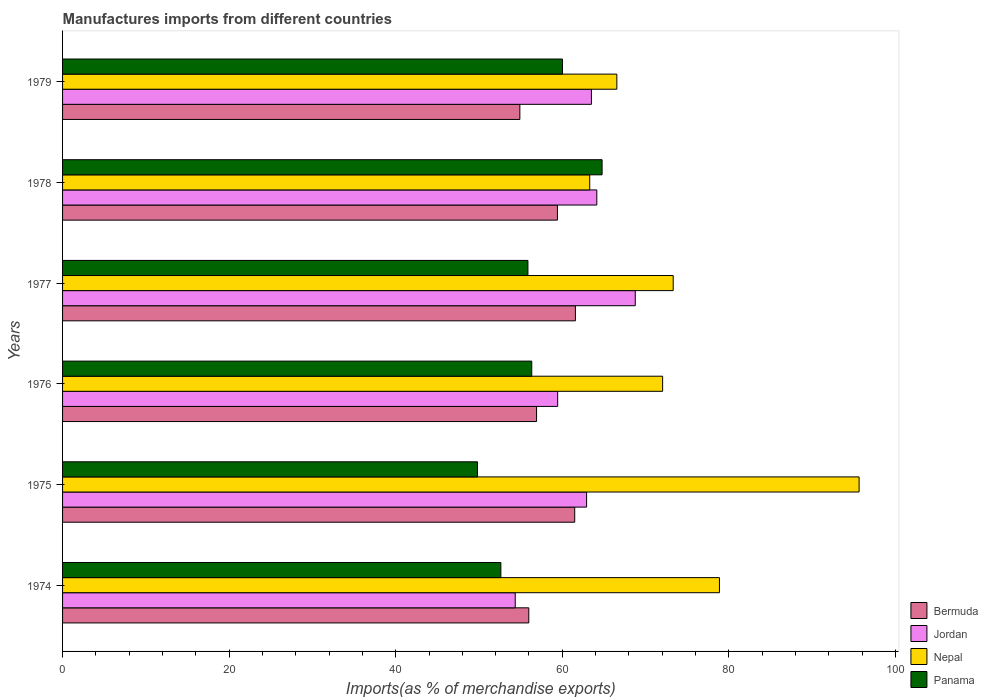How many different coloured bars are there?
Ensure brevity in your answer.  4. How many groups of bars are there?
Your answer should be compact. 6. Are the number of bars per tick equal to the number of legend labels?
Provide a short and direct response. Yes. What is the label of the 3rd group of bars from the top?
Your answer should be very brief. 1977. In how many cases, is the number of bars for a given year not equal to the number of legend labels?
Your response must be concise. 0. What is the percentage of imports to different countries in Panama in 1975?
Provide a short and direct response. 49.82. Across all years, what is the maximum percentage of imports to different countries in Jordan?
Provide a short and direct response. 68.76. Across all years, what is the minimum percentage of imports to different countries in Bermuda?
Offer a terse response. 54.91. In which year was the percentage of imports to different countries in Nepal maximum?
Your answer should be compact. 1975. In which year was the percentage of imports to different countries in Bermuda minimum?
Give a very brief answer. 1979. What is the total percentage of imports to different countries in Bermuda in the graph?
Ensure brevity in your answer.  350.29. What is the difference between the percentage of imports to different countries in Jordan in 1974 and that in 1979?
Give a very brief answer. -9.15. What is the difference between the percentage of imports to different countries in Bermuda in 1978 and the percentage of imports to different countries in Panama in 1976?
Provide a succinct answer. 3.08. What is the average percentage of imports to different countries in Nepal per year?
Offer a terse response. 74.95. In the year 1979, what is the difference between the percentage of imports to different countries in Bermuda and percentage of imports to different countries in Panama?
Your answer should be very brief. -5.12. What is the ratio of the percentage of imports to different countries in Nepal in 1975 to that in 1979?
Ensure brevity in your answer.  1.44. Is the difference between the percentage of imports to different countries in Bermuda in 1976 and 1977 greater than the difference between the percentage of imports to different countries in Panama in 1976 and 1977?
Your answer should be very brief. No. What is the difference between the highest and the second highest percentage of imports to different countries in Nepal?
Give a very brief answer. 16.77. What is the difference between the highest and the lowest percentage of imports to different countries in Panama?
Provide a succinct answer. 14.96. In how many years, is the percentage of imports to different countries in Jordan greater than the average percentage of imports to different countries in Jordan taken over all years?
Ensure brevity in your answer.  4. What does the 1st bar from the top in 1977 represents?
Your response must be concise. Panama. What does the 4th bar from the bottom in 1977 represents?
Ensure brevity in your answer.  Panama. How many bars are there?
Provide a succinct answer. 24. Are all the bars in the graph horizontal?
Make the answer very short. Yes. What is the difference between two consecutive major ticks on the X-axis?
Your answer should be compact. 20. Does the graph contain grids?
Provide a short and direct response. No. Where does the legend appear in the graph?
Your response must be concise. Bottom right. How many legend labels are there?
Your answer should be very brief. 4. How are the legend labels stacked?
Provide a short and direct response. Vertical. What is the title of the graph?
Your answer should be very brief. Manufactures imports from different countries. Does "Burundi" appear as one of the legend labels in the graph?
Provide a short and direct response. No. What is the label or title of the X-axis?
Offer a terse response. Imports(as % of merchandise exports). What is the label or title of the Y-axis?
Give a very brief answer. Years. What is the Imports(as % of merchandise exports) in Bermuda in 1974?
Offer a very short reply. 55.98. What is the Imports(as % of merchandise exports) in Jordan in 1974?
Your answer should be compact. 54.35. What is the Imports(as % of merchandise exports) in Nepal in 1974?
Offer a very short reply. 78.87. What is the Imports(as % of merchandise exports) of Panama in 1974?
Provide a succinct answer. 52.63. What is the Imports(as % of merchandise exports) of Bermuda in 1975?
Make the answer very short. 61.49. What is the Imports(as % of merchandise exports) in Jordan in 1975?
Your answer should be very brief. 62.92. What is the Imports(as % of merchandise exports) of Nepal in 1975?
Give a very brief answer. 95.64. What is the Imports(as % of merchandise exports) in Panama in 1975?
Offer a terse response. 49.82. What is the Imports(as % of merchandise exports) in Bermuda in 1976?
Offer a very short reply. 56.91. What is the Imports(as % of merchandise exports) of Jordan in 1976?
Offer a terse response. 59.45. What is the Imports(as % of merchandise exports) of Nepal in 1976?
Provide a short and direct response. 72.05. What is the Imports(as % of merchandise exports) in Panama in 1976?
Ensure brevity in your answer.  56.34. What is the Imports(as % of merchandise exports) of Bermuda in 1977?
Provide a succinct answer. 61.58. What is the Imports(as % of merchandise exports) in Jordan in 1977?
Offer a terse response. 68.76. What is the Imports(as % of merchandise exports) of Nepal in 1977?
Your response must be concise. 73.32. What is the Imports(as % of merchandise exports) of Panama in 1977?
Your answer should be compact. 55.88. What is the Imports(as % of merchandise exports) of Bermuda in 1978?
Offer a terse response. 59.42. What is the Imports(as % of merchandise exports) in Jordan in 1978?
Make the answer very short. 64.15. What is the Imports(as % of merchandise exports) in Nepal in 1978?
Offer a very short reply. 63.3. What is the Imports(as % of merchandise exports) of Panama in 1978?
Offer a very short reply. 64.78. What is the Imports(as % of merchandise exports) in Bermuda in 1979?
Provide a succinct answer. 54.91. What is the Imports(as % of merchandise exports) of Jordan in 1979?
Make the answer very short. 63.5. What is the Imports(as % of merchandise exports) in Nepal in 1979?
Ensure brevity in your answer.  66.55. What is the Imports(as % of merchandise exports) in Panama in 1979?
Ensure brevity in your answer.  60.02. Across all years, what is the maximum Imports(as % of merchandise exports) of Bermuda?
Make the answer very short. 61.58. Across all years, what is the maximum Imports(as % of merchandise exports) of Jordan?
Give a very brief answer. 68.76. Across all years, what is the maximum Imports(as % of merchandise exports) of Nepal?
Provide a short and direct response. 95.64. Across all years, what is the maximum Imports(as % of merchandise exports) in Panama?
Ensure brevity in your answer.  64.78. Across all years, what is the minimum Imports(as % of merchandise exports) in Bermuda?
Offer a terse response. 54.91. Across all years, what is the minimum Imports(as % of merchandise exports) of Jordan?
Your answer should be very brief. 54.35. Across all years, what is the minimum Imports(as % of merchandise exports) of Nepal?
Ensure brevity in your answer.  63.3. Across all years, what is the minimum Imports(as % of merchandise exports) in Panama?
Offer a terse response. 49.82. What is the total Imports(as % of merchandise exports) in Bermuda in the graph?
Keep it short and to the point. 350.29. What is the total Imports(as % of merchandise exports) in Jordan in the graph?
Offer a very short reply. 373.13. What is the total Imports(as % of merchandise exports) of Nepal in the graph?
Your response must be concise. 449.73. What is the total Imports(as % of merchandise exports) of Panama in the graph?
Ensure brevity in your answer.  339.46. What is the difference between the Imports(as % of merchandise exports) in Bermuda in 1974 and that in 1975?
Your answer should be very brief. -5.51. What is the difference between the Imports(as % of merchandise exports) in Jordan in 1974 and that in 1975?
Give a very brief answer. -8.57. What is the difference between the Imports(as % of merchandise exports) of Nepal in 1974 and that in 1975?
Offer a very short reply. -16.77. What is the difference between the Imports(as % of merchandise exports) in Panama in 1974 and that in 1975?
Give a very brief answer. 2.81. What is the difference between the Imports(as % of merchandise exports) in Bermuda in 1974 and that in 1976?
Give a very brief answer. -0.93. What is the difference between the Imports(as % of merchandise exports) in Jordan in 1974 and that in 1976?
Your answer should be compact. -5.1. What is the difference between the Imports(as % of merchandise exports) in Nepal in 1974 and that in 1976?
Your response must be concise. 6.82. What is the difference between the Imports(as % of merchandise exports) of Panama in 1974 and that in 1976?
Offer a terse response. -3.71. What is the difference between the Imports(as % of merchandise exports) of Bermuda in 1974 and that in 1977?
Offer a terse response. -5.6. What is the difference between the Imports(as % of merchandise exports) of Jordan in 1974 and that in 1977?
Your response must be concise. -14.41. What is the difference between the Imports(as % of merchandise exports) in Nepal in 1974 and that in 1977?
Offer a terse response. 5.55. What is the difference between the Imports(as % of merchandise exports) of Panama in 1974 and that in 1977?
Keep it short and to the point. -3.25. What is the difference between the Imports(as % of merchandise exports) in Bermuda in 1974 and that in 1978?
Give a very brief answer. -3.44. What is the difference between the Imports(as % of merchandise exports) of Jordan in 1974 and that in 1978?
Your answer should be very brief. -9.79. What is the difference between the Imports(as % of merchandise exports) of Nepal in 1974 and that in 1978?
Your response must be concise. 15.58. What is the difference between the Imports(as % of merchandise exports) of Panama in 1974 and that in 1978?
Make the answer very short. -12.15. What is the difference between the Imports(as % of merchandise exports) of Bermuda in 1974 and that in 1979?
Provide a short and direct response. 1.07. What is the difference between the Imports(as % of merchandise exports) in Jordan in 1974 and that in 1979?
Make the answer very short. -9.15. What is the difference between the Imports(as % of merchandise exports) of Nepal in 1974 and that in 1979?
Your response must be concise. 12.32. What is the difference between the Imports(as % of merchandise exports) in Panama in 1974 and that in 1979?
Provide a short and direct response. -7.4. What is the difference between the Imports(as % of merchandise exports) of Bermuda in 1975 and that in 1976?
Your response must be concise. 4.58. What is the difference between the Imports(as % of merchandise exports) of Jordan in 1975 and that in 1976?
Your answer should be compact. 3.47. What is the difference between the Imports(as % of merchandise exports) of Nepal in 1975 and that in 1976?
Offer a terse response. 23.59. What is the difference between the Imports(as % of merchandise exports) in Panama in 1975 and that in 1976?
Ensure brevity in your answer.  -6.52. What is the difference between the Imports(as % of merchandise exports) of Bermuda in 1975 and that in 1977?
Make the answer very short. -0.08. What is the difference between the Imports(as % of merchandise exports) of Jordan in 1975 and that in 1977?
Your answer should be compact. -5.84. What is the difference between the Imports(as % of merchandise exports) in Nepal in 1975 and that in 1977?
Your answer should be compact. 22.32. What is the difference between the Imports(as % of merchandise exports) of Panama in 1975 and that in 1977?
Offer a very short reply. -6.06. What is the difference between the Imports(as % of merchandise exports) of Bermuda in 1975 and that in 1978?
Offer a terse response. 2.08. What is the difference between the Imports(as % of merchandise exports) of Jordan in 1975 and that in 1978?
Offer a terse response. -1.23. What is the difference between the Imports(as % of merchandise exports) in Nepal in 1975 and that in 1978?
Your answer should be compact. 32.34. What is the difference between the Imports(as % of merchandise exports) of Panama in 1975 and that in 1978?
Provide a succinct answer. -14.96. What is the difference between the Imports(as % of merchandise exports) of Bermuda in 1975 and that in 1979?
Provide a succinct answer. 6.59. What is the difference between the Imports(as % of merchandise exports) of Jordan in 1975 and that in 1979?
Ensure brevity in your answer.  -0.58. What is the difference between the Imports(as % of merchandise exports) in Nepal in 1975 and that in 1979?
Provide a short and direct response. 29.09. What is the difference between the Imports(as % of merchandise exports) in Panama in 1975 and that in 1979?
Keep it short and to the point. -10.2. What is the difference between the Imports(as % of merchandise exports) of Bermuda in 1976 and that in 1977?
Give a very brief answer. -4.66. What is the difference between the Imports(as % of merchandise exports) in Jordan in 1976 and that in 1977?
Your answer should be very brief. -9.32. What is the difference between the Imports(as % of merchandise exports) in Nepal in 1976 and that in 1977?
Your answer should be very brief. -1.27. What is the difference between the Imports(as % of merchandise exports) in Panama in 1976 and that in 1977?
Your answer should be very brief. 0.46. What is the difference between the Imports(as % of merchandise exports) of Bermuda in 1976 and that in 1978?
Provide a short and direct response. -2.5. What is the difference between the Imports(as % of merchandise exports) in Jordan in 1976 and that in 1978?
Your answer should be compact. -4.7. What is the difference between the Imports(as % of merchandise exports) of Nepal in 1976 and that in 1978?
Your answer should be very brief. 8.75. What is the difference between the Imports(as % of merchandise exports) in Panama in 1976 and that in 1978?
Your answer should be very brief. -8.45. What is the difference between the Imports(as % of merchandise exports) of Bermuda in 1976 and that in 1979?
Offer a terse response. 2. What is the difference between the Imports(as % of merchandise exports) in Jordan in 1976 and that in 1979?
Keep it short and to the point. -4.05. What is the difference between the Imports(as % of merchandise exports) in Nepal in 1976 and that in 1979?
Provide a succinct answer. 5.5. What is the difference between the Imports(as % of merchandise exports) in Panama in 1976 and that in 1979?
Make the answer very short. -3.69. What is the difference between the Imports(as % of merchandise exports) in Bermuda in 1977 and that in 1978?
Provide a short and direct response. 2.16. What is the difference between the Imports(as % of merchandise exports) in Jordan in 1977 and that in 1978?
Provide a short and direct response. 4.62. What is the difference between the Imports(as % of merchandise exports) of Nepal in 1977 and that in 1978?
Your answer should be very brief. 10.02. What is the difference between the Imports(as % of merchandise exports) of Panama in 1977 and that in 1978?
Give a very brief answer. -8.91. What is the difference between the Imports(as % of merchandise exports) in Bermuda in 1977 and that in 1979?
Give a very brief answer. 6.67. What is the difference between the Imports(as % of merchandise exports) of Jordan in 1977 and that in 1979?
Ensure brevity in your answer.  5.26. What is the difference between the Imports(as % of merchandise exports) in Nepal in 1977 and that in 1979?
Give a very brief answer. 6.77. What is the difference between the Imports(as % of merchandise exports) in Panama in 1977 and that in 1979?
Provide a succinct answer. -4.15. What is the difference between the Imports(as % of merchandise exports) in Bermuda in 1978 and that in 1979?
Keep it short and to the point. 4.51. What is the difference between the Imports(as % of merchandise exports) of Jordan in 1978 and that in 1979?
Make the answer very short. 0.65. What is the difference between the Imports(as % of merchandise exports) in Nepal in 1978 and that in 1979?
Keep it short and to the point. -3.26. What is the difference between the Imports(as % of merchandise exports) in Panama in 1978 and that in 1979?
Provide a succinct answer. 4.76. What is the difference between the Imports(as % of merchandise exports) in Bermuda in 1974 and the Imports(as % of merchandise exports) in Jordan in 1975?
Your answer should be very brief. -6.94. What is the difference between the Imports(as % of merchandise exports) in Bermuda in 1974 and the Imports(as % of merchandise exports) in Nepal in 1975?
Your answer should be compact. -39.66. What is the difference between the Imports(as % of merchandise exports) in Bermuda in 1974 and the Imports(as % of merchandise exports) in Panama in 1975?
Provide a succinct answer. 6.16. What is the difference between the Imports(as % of merchandise exports) of Jordan in 1974 and the Imports(as % of merchandise exports) of Nepal in 1975?
Your answer should be very brief. -41.29. What is the difference between the Imports(as % of merchandise exports) in Jordan in 1974 and the Imports(as % of merchandise exports) in Panama in 1975?
Your answer should be compact. 4.53. What is the difference between the Imports(as % of merchandise exports) of Nepal in 1974 and the Imports(as % of merchandise exports) of Panama in 1975?
Give a very brief answer. 29.05. What is the difference between the Imports(as % of merchandise exports) of Bermuda in 1974 and the Imports(as % of merchandise exports) of Jordan in 1976?
Give a very brief answer. -3.47. What is the difference between the Imports(as % of merchandise exports) in Bermuda in 1974 and the Imports(as % of merchandise exports) in Nepal in 1976?
Your answer should be compact. -16.07. What is the difference between the Imports(as % of merchandise exports) in Bermuda in 1974 and the Imports(as % of merchandise exports) in Panama in 1976?
Your answer should be very brief. -0.36. What is the difference between the Imports(as % of merchandise exports) of Jordan in 1974 and the Imports(as % of merchandise exports) of Nepal in 1976?
Offer a terse response. -17.7. What is the difference between the Imports(as % of merchandise exports) in Jordan in 1974 and the Imports(as % of merchandise exports) in Panama in 1976?
Your response must be concise. -1.98. What is the difference between the Imports(as % of merchandise exports) of Nepal in 1974 and the Imports(as % of merchandise exports) of Panama in 1976?
Offer a very short reply. 22.54. What is the difference between the Imports(as % of merchandise exports) of Bermuda in 1974 and the Imports(as % of merchandise exports) of Jordan in 1977?
Your answer should be very brief. -12.78. What is the difference between the Imports(as % of merchandise exports) of Bermuda in 1974 and the Imports(as % of merchandise exports) of Nepal in 1977?
Provide a succinct answer. -17.34. What is the difference between the Imports(as % of merchandise exports) in Bermuda in 1974 and the Imports(as % of merchandise exports) in Panama in 1977?
Make the answer very short. 0.1. What is the difference between the Imports(as % of merchandise exports) of Jordan in 1974 and the Imports(as % of merchandise exports) of Nepal in 1977?
Your response must be concise. -18.97. What is the difference between the Imports(as % of merchandise exports) of Jordan in 1974 and the Imports(as % of merchandise exports) of Panama in 1977?
Your answer should be very brief. -1.52. What is the difference between the Imports(as % of merchandise exports) of Nepal in 1974 and the Imports(as % of merchandise exports) of Panama in 1977?
Make the answer very short. 23. What is the difference between the Imports(as % of merchandise exports) of Bermuda in 1974 and the Imports(as % of merchandise exports) of Jordan in 1978?
Your answer should be compact. -8.17. What is the difference between the Imports(as % of merchandise exports) in Bermuda in 1974 and the Imports(as % of merchandise exports) in Nepal in 1978?
Ensure brevity in your answer.  -7.32. What is the difference between the Imports(as % of merchandise exports) of Bermuda in 1974 and the Imports(as % of merchandise exports) of Panama in 1978?
Your response must be concise. -8.8. What is the difference between the Imports(as % of merchandise exports) of Jordan in 1974 and the Imports(as % of merchandise exports) of Nepal in 1978?
Make the answer very short. -8.94. What is the difference between the Imports(as % of merchandise exports) of Jordan in 1974 and the Imports(as % of merchandise exports) of Panama in 1978?
Provide a short and direct response. -10.43. What is the difference between the Imports(as % of merchandise exports) in Nepal in 1974 and the Imports(as % of merchandise exports) in Panama in 1978?
Your answer should be very brief. 14.09. What is the difference between the Imports(as % of merchandise exports) of Bermuda in 1974 and the Imports(as % of merchandise exports) of Jordan in 1979?
Give a very brief answer. -7.52. What is the difference between the Imports(as % of merchandise exports) of Bermuda in 1974 and the Imports(as % of merchandise exports) of Nepal in 1979?
Your answer should be compact. -10.57. What is the difference between the Imports(as % of merchandise exports) in Bermuda in 1974 and the Imports(as % of merchandise exports) in Panama in 1979?
Your answer should be compact. -4.04. What is the difference between the Imports(as % of merchandise exports) in Jordan in 1974 and the Imports(as % of merchandise exports) in Nepal in 1979?
Ensure brevity in your answer.  -12.2. What is the difference between the Imports(as % of merchandise exports) in Jordan in 1974 and the Imports(as % of merchandise exports) in Panama in 1979?
Provide a succinct answer. -5.67. What is the difference between the Imports(as % of merchandise exports) of Nepal in 1974 and the Imports(as % of merchandise exports) of Panama in 1979?
Your answer should be compact. 18.85. What is the difference between the Imports(as % of merchandise exports) of Bermuda in 1975 and the Imports(as % of merchandise exports) of Jordan in 1976?
Your response must be concise. 2.05. What is the difference between the Imports(as % of merchandise exports) in Bermuda in 1975 and the Imports(as % of merchandise exports) in Nepal in 1976?
Give a very brief answer. -10.56. What is the difference between the Imports(as % of merchandise exports) in Bermuda in 1975 and the Imports(as % of merchandise exports) in Panama in 1976?
Your answer should be very brief. 5.16. What is the difference between the Imports(as % of merchandise exports) of Jordan in 1975 and the Imports(as % of merchandise exports) of Nepal in 1976?
Your answer should be compact. -9.13. What is the difference between the Imports(as % of merchandise exports) of Jordan in 1975 and the Imports(as % of merchandise exports) of Panama in 1976?
Offer a very short reply. 6.59. What is the difference between the Imports(as % of merchandise exports) of Nepal in 1975 and the Imports(as % of merchandise exports) of Panama in 1976?
Make the answer very short. 39.3. What is the difference between the Imports(as % of merchandise exports) in Bermuda in 1975 and the Imports(as % of merchandise exports) in Jordan in 1977?
Ensure brevity in your answer.  -7.27. What is the difference between the Imports(as % of merchandise exports) of Bermuda in 1975 and the Imports(as % of merchandise exports) of Nepal in 1977?
Offer a very short reply. -11.83. What is the difference between the Imports(as % of merchandise exports) in Bermuda in 1975 and the Imports(as % of merchandise exports) in Panama in 1977?
Provide a succinct answer. 5.62. What is the difference between the Imports(as % of merchandise exports) in Jordan in 1975 and the Imports(as % of merchandise exports) in Nepal in 1977?
Offer a terse response. -10.4. What is the difference between the Imports(as % of merchandise exports) in Jordan in 1975 and the Imports(as % of merchandise exports) in Panama in 1977?
Your answer should be compact. 7.05. What is the difference between the Imports(as % of merchandise exports) in Nepal in 1975 and the Imports(as % of merchandise exports) in Panama in 1977?
Keep it short and to the point. 39.76. What is the difference between the Imports(as % of merchandise exports) of Bermuda in 1975 and the Imports(as % of merchandise exports) of Jordan in 1978?
Your answer should be very brief. -2.65. What is the difference between the Imports(as % of merchandise exports) of Bermuda in 1975 and the Imports(as % of merchandise exports) of Nepal in 1978?
Your answer should be very brief. -1.8. What is the difference between the Imports(as % of merchandise exports) of Bermuda in 1975 and the Imports(as % of merchandise exports) of Panama in 1978?
Provide a succinct answer. -3.29. What is the difference between the Imports(as % of merchandise exports) in Jordan in 1975 and the Imports(as % of merchandise exports) in Nepal in 1978?
Ensure brevity in your answer.  -0.37. What is the difference between the Imports(as % of merchandise exports) of Jordan in 1975 and the Imports(as % of merchandise exports) of Panama in 1978?
Give a very brief answer. -1.86. What is the difference between the Imports(as % of merchandise exports) of Nepal in 1975 and the Imports(as % of merchandise exports) of Panama in 1978?
Your answer should be very brief. 30.86. What is the difference between the Imports(as % of merchandise exports) in Bermuda in 1975 and the Imports(as % of merchandise exports) in Jordan in 1979?
Keep it short and to the point. -2.01. What is the difference between the Imports(as % of merchandise exports) of Bermuda in 1975 and the Imports(as % of merchandise exports) of Nepal in 1979?
Provide a short and direct response. -5.06. What is the difference between the Imports(as % of merchandise exports) in Bermuda in 1975 and the Imports(as % of merchandise exports) in Panama in 1979?
Offer a terse response. 1.47. What is the difference between the Imports(as % of merchandise exports) in Jordan in 1975 and the Imports(as % of merchandise exports) in Nepal in 1979?
Provide a short and direct response. -3.63. What is the difference between the Imports(as % of merchandise exports) of Jordan in 1975 and the Imports(as % of merchandise exports) of Panama in 1979?
Give a very brief answer. 2.9. What is the difference between the Imports(as % of merchandise exports) in Nepal in 1975 and the Imports(as % of merchandise exports) in Panama in 1979?
Ensure brevity in your answer.  35.62. What is the difference between the Imports(as % of merchandise exports) in Bermuda in 1976 and the Imports(as % of merchandise exports) in Jordan in 1977?
Provide a succinct answer. -11.85. What is the difference between the Imports(as % of merchandise exports) in Bermuda in 1976 and the Imports(as % of merchandise exports) in Nepal in 1977?
Keep it short and to the point. -16.41. What is the difference between the Imports(as % of merchandise exports) of Bermuda in 1976 and the Imports(as % of merchandise exports) of Panama in 1977?
Ensure brevity in your answer.  1.04. What is the difference between the Imports(as % of merchandise exports) of Jordan in 1976 and the Imports(as % of merchandise exports) of Nepal in 1977?
Give a very brief answer. -13.87. What is the difference between the Imports(as % of merchandise exports) in Jordan in 1976 and the Imports(as % of merchandise exports) in Panama in 1977?
Your answer should be compact. 3.57. What is the difference between the Imports(as % of merchandise exports) of Nepal in 1976 and the Imports(as % of merchandise exports) of Panama in 1977?
Ensure brevity in your answer.  16.17. What is the difference between the Imports(as % of merchandise exports) in Bermuda in 1976 and the Imports(as % of merchandise exports) in Jordan in 1978?
Provide a short and direct response. -7.23. What is the difference between the Imports(as % of merchandise exports) in Bermuda in 1976 and the Imports(as % of merchandise exports) in Nepal in 1978?
Your response must be concise. -6.38. What is the difference between the Imports(as % of merchandise exports) in Bermuda in 1976 and the Imports(as % of merchandise exports) in Panama in 1978?
Ensure brevity in your answer.  -7.87. What is the difference between the Imports(as % of merchandise exports) of Jordan in 1976 and the Imports(as % of merchandise exports) of Nepal in 1978?
Make the answer very short. -3.85. What is the difference between the Imports(as % of merchandise exports) of Jordan in 1976 and the Imports(as % of merchandise exports) of Panama in 1978?
Keep it short and to the point. -5.33. What is the difference between the Imports(as % of merchandise exports) in Nepal in 1976 and the Imports(as % of merchandise exports) in Panama in 1978?
Make the answer very short. 7.27. What is the difference between the Imports(as % of merchandise exports) in Bermuda in 1976 and the Imports(as % of merchandise exports) in Jordan in 1979?
Offer a terse response. -6.59. What is the difference between the Imports(as % of merchandise exports) of Bermuda in 1976 and the Imports(as % of merchandise exports) of Nepal in 1979?
Offer a terse response. -9.64. What is the difference between the Imports(as % of merchandise exports) in Bermuda in 1976 and the Imports(as % of merchandise exports) in Panama in 1979?
Your answer should be very brief. -3.11. What is the difference between the Imports(as % of merchandise exports) of Jordan in 1976 and the Imports(as % of merchandise exports) of Nepal in 1979?
Make the answer very short. -7.1. What is the difference between the Imports(as % of merchandise exports) in Jordan in 1976 and the Imports(as % of merchandise exports) in Panama in 1979?
Your answer should be compact. -0.57. What is the difference between the Imports(as % of merchandise exports) of Nepal in 1976 and the Imports(as % of merchandise exports) of Panama in 1979?
Provide a succinct answer. 12.03. What is the difference between the Imports(as % of merchandise exports) in Bermuda in 1977 and the Imports(as % of merchandise exports) in Jordan in 1978?
Offer a very short reply. -2.57. What is the difference between the Imports(as % of merchandise exports) in Bermuda in 1977 and the Imports(as % of merchandise exports) in Nepal in 1978?
Provide a succinct answer. -1.72. What is the difference between the Imports(as % of merchandise exports) of Bermuda in 1977 and the Imports(as % of merchandise exports) of Panama in 1978?
Your answer should be compact. -3.2. What is the difference between the Imports(as % of merchandise exports) in Jordan in 1977 and the Imports(as % of merchandise exports) in Nepal in 1978?
Provide a short and direct response. 5.47. What is the difference between the Imports(as % of merchandise exports) in Jordan in 1977 and the Imports(as % of merchandise exports) in Panama in 1978?
Give a very brief answer. 3.98. What is the difference between the Imports(as % of merchandise exports) of Nepal in 1977 and the Imports(as % of merchandise exports) of Panama in 1978?
Provide a succinct answer. 8.54. What is the difference between the Imports(as % of merchandise exports) of Bermuda in 1977 and the Imports(as % of merchandise exports) of Jordan in 1979?
Ensure brevity in your answer.  -1.92. What is the difference between the Imports(as % of merchandise exports) in Bermuda in 1977 and the Imports(as % of merchandise exports) in Nepal in 1979?
Give a very brief answer. -4.98. What is the difference between the Imports(as % of merchandise exports) of Bermuda in 1977 and the Imports(as % of merchandise exports) of Panama in 1979?
Give a very brief answer. 1.55. What is the difference between the Imports(as % of merchandise exports) of Jordan in 1977 and the Imports(as % of merchandise exports) of Nepal in 1979?
Your answer should be very brief. 2.21. What is the difference between the Imports(as % of merchandise exports) of Jordan in 1977 and the Imports(as % of merchandise exports) of Panama in 1979?
Give a very brief answer. 8.74. What is the difference between the Imports(as % of merchandise exports) in Nepal in 1977 and the Imports(as % of merchandise exports) in Panama in 1979?
Provide a succinct answer. 13.3. What is the difference between the Imports(as % of merchandise exports) in Bermuda in 1978 and the Imports(as % of merchandise exports) in Jordan in 1979?
Ensure brevity in your answer.  -4.08. What is the difference between the Imports(as % of merchandise exports) of Bermuda in 1978 and the Imports(as % of merchandise exports) of Nepal in 1979?
Your answer should be compact. -7.14. What is the difference between the Imports(as % of merchandise exports) of Bermuda in 1978 and the Imports(as % of merchandise exports) of Panama in 1979?
Offer a terse response. -0.61. What is the difference between the Imports(as % of merchandise exports) of Jordan in 1978 and the Imports(as % of merchandise exports) of Nepal in 1979?
Your answer should be very brief. -2.41. What is the difference between the Imports(as % of merchandise exports) of Jordan in 1978 and the Imports(as % of merchandise exports) of Panama in 1979?
Ensure brevity in your answer.  4.12. What is the difference between the Imports(as % of merchandise exports) in Nepal in 1978 and the Imports(as % of merchandise exports) in Panama in 1979?
Give a very brief answer. 3.27. What is the average Imports(as % of merchandise exports) of Bermuda per year?
Your answer should be compact. 58.38. What is the average Imports(as % of merchandise exports) of Jordan per year?
Make the answer very short. 62.19. What is the average Imports(as % of merchandise exports) in Nepal per year?
Your response must be concise. 74.95. What is the average Imports(as % of merchandise exports) of Panama per year?
Provide a succinct answer. 56.58. In the year 1974, what is the difference between the Imports(as % of merchandise exports) in Bermuda and Imports(as % of merchandise exports) in Jordan?
Your response must be concise. 1.63. In the year 1974, what is the difference between the Imports(as % of merchandise exports) of Bermuda and Imports(as % of merchandise exports) of Nepal?
Make the answer very short. -22.89. In the year 1974, what is the difference between the Imports(as % of merchandise exports) in Bermuda and Imports(as % of merchandise exports) in Panama?
Your response must be concise. 3.35. In the year 1974, what is the difference between the Imports(as % of merchandise exports) of Jordan and Imports(as % of merchandise exports) of Nepal?
Make the answer very short. -24.52. In the year 1974, what is the difference between the Imports(as % of merchandise exports) in Jordan and Imports(as % of merchandise exports) in Panama?
Your answer should be compact. 1.73. In the year 1974, what is the difference between the Imports(as % of merchandise exports) of Nepal and Imports(as % of merchandise exports) of Panama?
Provide a short and direct response. 26.25. In the year 1975, what is the difference between the Imports(as % of merchandise exports) in Bermuda and Imports(as % of merchandise exports) in Jordan?
Give a very brief answer. -1.43. In the year 1975, what is the difference between the Imports(as % of merchandise exports) of Bermuda and Imports(as % of merchandise exports) of Nepal?
Give a very brief answer. -34.14. In the year 1975, what is the difference between the Imports(as % of merchandise exports) of Bermuda and Imports(as % of merchandise exports) of Panama?
Offer a very short reply. 11.68. In the year 1975, what is the difference between the Imports(as % of merchandise exports) in Jordan and Imports(as % of merchandise exports) in Nepal?
Your response must be concise. -32.72. In the year 1975, what is the difference between the Imports(as % of merchandise exports) of Jordan and Imports(as % of merchandise exports) of Panama?
Make the answer very short. 13.1. In the year 1975, what is the difference between the Imports(as % of merchandise exports) in Nepal and Imports(as % of merchandise exports) in Panama?
Offer a terse response. 45.82. In the year 1976, what is the difference between the Imports(as % of merchandise exports) in Bermuda and Imports(as % of merchandise exports) in Jordan?
Your answer should be compact. -2.54. In the year 1976, what is the difference between the Imports(as % of merchandise exports) of Bermuda and Imports(as % of merchandise exports) of Nepal?
Your answer should be compact. -15.14. In the year 1976, what is the difference between the Imports(as % of merchandise exports) in Bermuda and Imports(as % of merchandise exports) in Panama?
Your response must be concise. 0.58. In the year 1976, what is the difference between the Imports(as % of merchandise exports) of Jordan and Imports(as % of merchandise exports) of Nepal?
Your answer should be compact. -12.6. In the year 1976, what is the difference between the Imports(as % of merchandise exports) in Jordan and Imports(as % of merchandise exports) in Panama?
Your answer should be compact. 3.11. In the year 1976, what is the difference between the Imports(as % of merchandise exports) in Nepal and Imports(as % of merchandise exports) in Panama?
Ensure brevity in your answer.  15.71. In the year 1977, what is the difference between the Imports(as % of merchandise exports) in Bermuda and Imports(as % of merchandise exports) in Jordan?
Your answer should be very brief. -7.19. In the year 1977, what is the difference between the Imports(as % of merchandise exports) of Bermuda and Imports(as % of merchandise exports) of Nepal?
Keep it short and to the point. -11.74. In the year 1977, what is the difference between the Imports(as % of merchandise exports) in Bermuda and Imports(as % of merchandise exports) in Panama?
Ensure brevity in your answer.  5.7. In the year 1977, what is the difference between the Imports(as % of merchandise exports) in Jordan and Imports(as % of merchandise exports) in Nepal?
Offer a terse response. -4.56. In the year 1977, what is the difference between the Imports(as % of merchandise exports) in Jordan and Imports(as % of merchandise exports) in Panama?
Your answer should be compact. 12.89. In the year 1977, what is the difference between the Imports(as % of merchandise exports) in Nepal and Imports(as % of merchandise exports) in Panama?
Give a very brief answer. 17.45. In the year 1978, what is the difference between the Imports(as % of merchandise exports) of Bermuda and Imports(as % of merchandise exports) of Jordan?
Your answer should be very brief. -4.73. In the year 1978, what is the difference between the Imports(as % of merchandise exports) of Bermuda and Imports(as % of merchandise exports) of Nepal?
Give a very brief answer. -3.88. In the year 1978, what is the difference between the Imports(as % of merchandise exports) of Bermuda and Imports(as % of merchandise exports) of Panama?
Offer a terse response. -5.36. In the year 1978, what is the difference between the Imports(as % of merchandise exports) of Jordan and Imports(as % of merchandise exports) of Nepal?
Make the answer very short. 0.85. In the year 1978, what is the difference between the Imports(as % of merchandise exports) of Jordan and Imports(as % of merchandise exports) of Panama?
Provide a short and direct response. -0.63. In the year 1978, what is the difference between the Imports(as % of merchandise exports) of Nepal and Imports(as % of merchandise exports) of Panama?
Your response must be concise. -1.49. In the year 1979, what is the difference between the Imports(as % of merchandise exports) of Bermuda and Imports(as % of merchandise exports) of Jordan?
Ensure brevity in your answer.  -8.59. In the year 1979, what is the difference between the Imports(as % of merchandise exports) of Bermuda and Imports(as % of merchandise exports) of Nepal?
Make the answer very short. -11.64. In the year 1979, what is the difference between the Imports(as % of merchandise exports) in Bermuda and Imports(as % of merchandise exports) in Panama?
Your response must be concise. -5.12. In the year 1979, what is the difference between the Imports(as % of merchandise exports) in Jordan and Imports(as % of merchandise exports) in Nepal?
Give a very brief answer. -3.05. In the year 1979, what is the difference between the Imports(as % of merchandise exports) in Jordan and Imports(as % of merchandise exports) in Panama?
Give a very brief answer. 3.48. In the year 1979, what is the difference between the Imports(as % of merchandise exports) of Nepal and Imports(as % of merchandise exports) of Panama?
Provide a succinct answer. 6.53. What is the ratio of the Imports(as % of merchandise exports) in Bermuda in 1974 to that in 1975?
Provide a short and direct response. 0.91. What is the ratio of the Imports(as % of merchandise exports) in Jordan in 1974 to that in 1975?
Your answer should be compact. 0.86. What is the ratio of the Imports(as % of merchandise exports) in Nepal in 1974 to that in 1975?
Offer a terse response. 0.82. What is the ratio of the Imports(as % of merchandise exports) in Panama in 1974 to that in 1975?
Your response must be concise. 1.06. What is the ratio of the Imports(as % of merchandise exports) of Bermuda in 1974 to that in 1976?
Offer a terse response. 0.98. What is the ratio of the Imports(as % of merchandise exports) of Jordan in 1974 to that in 1976?
Make the answer very short. 0.91. What is the ratio of the Imports(as % of merchandise exports) in Nepal in 1974 to that in 1976?
Your answer should be compact. 1.09. What is the ratio of the Imports(as % of merchandise exports) in Panama in 1974 to that in 1976?
Your answer should be compact. 0.93. What is the ratio of the Imports(as % of merchandise exports) in Jordan in 1974 to that in 1977?
Make the answer very short. 0.79. What is the ratio of the Imports(as % of merchandise exports) of Nepal in 1974 to that in 1977?
Make the answer very short. 1.08. What is the ratio of the Imports(as % of merchandise exports) in Panama in 1974 to that in 1977?
Make the answer very short. 0.94. What is the ratio of the Imports(as % of merchandise exports) of Bermuda in 1974 to that in 1978?
Your answer should be compact. 0.94. What is the ratio of the Imports(as % of merchandise exports) in Jordan in 1974 to that in 1978?
Provide a succinct answer. 0.85. What is the ratio of the Imports(as % of merchandise exports) in Nepal in 1974 to that in 1978?
Your response must be concise. 1.25. What is the ratio of the Imports(as % of merchandise exports) of Panama in 1974 to that in 1978?
Your answer should be compact. 0.81. What is the ratio of the Imports(as % of merchandise exports) in Bermuda in 1974 to that in 1979?
Make the answer very short. 1.02. What is the ratio of the Imports(as % of merchandise exports) in Jordan in 1974 to that in 1979?
Offer a terse response. 0.86. What is the ratio of the Imports(as % of merchandise exports) in Nepal in 1974 to that in 1979?
Provide a succinct answer. 1.19. What is the ratio of the Imports(as % of merchandise exports) of Panama in 1974 to that in 1979?
Provide a short and direct response. 0.88. What is the ratio of the Imports(as % of merchandise exports) in Bermuda in 1975 to that in 1976?
Offer a terse response. 1.08. What is the ratio of the Imports(as % of merchandise exports) in Jordan in 1975 to that in 1976?
Offer a very short reply. 1.06. What is the ratio of the Imports(as % of merchandise exports) in Nepal in 1975 to that in 1976?
Make the answer very short. 1.33. What is the ratio of the Imports(as % of merchandise exports) of Panama in 1975 to that in 1976?
Your answer should be compact. 0.88. What is the ratio of the Imports(as % of merchandise exports) in Jordan in 1975 to that in 1977?
Your response must be concise. 0.92. What is the ratio of the Imports(as % of merchandise exports) in Nepal in 1975 to that in 1977?
Your answer should be very brief. 1.3. What is the ratio of the Imports(as % of merchandise exports) in Panama in 1975 to that in 1977?
Make the answer very short. 0.89. What is the ratio of the Imports(as % of merchandise exports) in Bermuda in 1975 to that in 1978?
Your answer should be very brief. 1.03. What is the ratio of the Imports(as % of merchandise exports) of Jordan in 1975 to that in 1978?
Make the answer very short. 0.98. What is the ratio of the Imports(as % of merchandise exports) in Nepal in 1975 to that in 1978?
Offer a terse response. 1.51. What is the ratio of the Imports(as % of merchandise exports) of Panama in 1975 to that in 1978?
Keep it short and to the point. 0.77. What is the ratio of the Imports(as % of merchandise exports) in Bermuda in 1975 to that in 1979?
Keep it short and to the point. 1.12. What is the ratio of the Imports(as % of merchandise exports) in Jordan in 1975 to that in 1979?
Your answer should be compact. 0.99. What is the ratio of the Imports(as % of merchandise exports) of Nepal in 1975 to that in 1979?
Your answer should be very brief. 1.44. What is the ratio of the Imports(as % of merchandise exports) in Panama in 1975 to that in 1979?
Keep it short and to the point. 0.83. What is the ratio of the Imports(as % of merchandise exports) of Bermuda in 1976 to that in 1977?
Your answer should be compact. 0.92. What is the ratio of the Imports(as % of merchandise exports) of Jordan in 1976 to that in 1977?
Offer a terse response. 0.86. What is the ratio of the Imports(as % of merchandise exports) of Nepal in 1976 to that in 1977?
Offer a terse response. 0.98. What is the ratio of the Imports(as % of merchandise exports) in Panama in 1976 to that in 1977?
Make the answer very short. 1.01. What is the ratio of the Imports(as % of merchandise exports) of Bermuda in 1976 to that in 1978?
Make the answer very short. 0.96. What is the ratio of the Imports(as % of merchandise exports) in Jordan in 1976 to that in 1978?
Your response must be concise. 0.93. What is the ratio of the Imports(as % of merchandise exports) in Nepal in 1976 to that in 1978?
Provide a short and direct response. 1.14. What is the ratio of the Imports(as % of merchandise exports) in Panama in 1976 to that in 1978?
Ensure brevity in your answer.  0.87. What is the ratio of the Imports(as % of merchandise exports) of Bermuda in 1976 to that in 1979?
Keep it short and to the point. 1.04. What is the ratio of the Imports(as % of merchandise exports) in Jordan in 1976 to that in 1979?
Ensure brevity in your answer.  0.94. What is the ratio of the Imports(as % of merchandise exports) in Nepal in 1976 to that in 1979?
Keep it short and to the point. 1.08. What is the ratio of the Imports(as % of merchandise exports) in Panama in 1976 to that in 1979?
Your answer should be very brief. 0.94. What is the ratio of the Imports(as % of merchandise exports) of Bermuda in 1977 to that in 1978?
Ensure brevity in your answer.  1.04. What is the ratio of the Imports(as % of merchandise exports) in Jordan in 1977 to that in 1978?
Make the answer very short. 1.07. What is the ratio of the Imports(as % of merchandise exports) in Nepal in 1977 to that in 1978?
Offer a terse response. 1.16. What is the ratio of the Imports(as % of merchandise exports) of Panama in 1977 to that in 1978?
Provide a succinct answer. 0.86. What is the ratio of the Imports(as % of merchandise exports) in Bermuda in 1977 to that in 1979?
Offer a terse response. 1.12. What is the ratio of the Imports(as % of merchandise exports) of Jordan in 1977 to that in 1979?
Your answer should be very brief. 1.08. What is the ratio of the Imports(as % of merchandise exports) of Nepal in 1977 to that in 1979?
Keep it short and to the point. 1.1. What is the ratio of the Imports(as % of merchandise exports) in Panama in 1977 to that in 1979?
Your answer should be compact. 0.93. What is the ratio of the Imports(as % of merchandise exports) in Bermuda in 1978 to that in 1979?
Keep it short and to the point. 1.08. What is the ratio of the Imports(as % of merchandise exports) in Jordan in 1978 to that in 1979?
Provide a short and direct response. 1.01. What is the ratio of the Imports(as % of merchandise exports) in Nepal in 1978 to that in 1979?
Make the answer very short. 0.95. What is the ratio of the Imports(as % of merchandise exports) of Panama in 1978 to that in 1979?
Your response must be concise. 1.08. What is the difference between the highest and the second highest Imports(as % of merchandise exports) in Bermuda?
Provide a succinct answer. 0.08. What is the difference between the highest and the second highest Imports(as % of merchandise exports) in Jordan?
Give a very brief answer. 4.62. What is the difference between the highest and the second highest Imports(as % of merchandise exports) of Nepal?
Keep it short and to the point. 16.77. What is the difference between the highest and the second highest Imports(as % of merchandise exports) of Panama?
Provide a short and direct response. 4.76. What is the difference between the highest and the lowest Imports(as % of merchandise exports) of Bermuda?
Provide a short and direct response. 6.67. What is the difference between the highest and the lowest Imports(as % of merchandise exports) of Jordan?
Provide a succinct answer. 14.41. What is the difference between the highest and the lowest Imports(as % of merchandise exports) of Nepal?
Provide a short and direct response. 32.34. What is the difference between the highest and the lowest Imports(as % of merchandise exports) in Panama?
Make the answer very short. 14.96. 